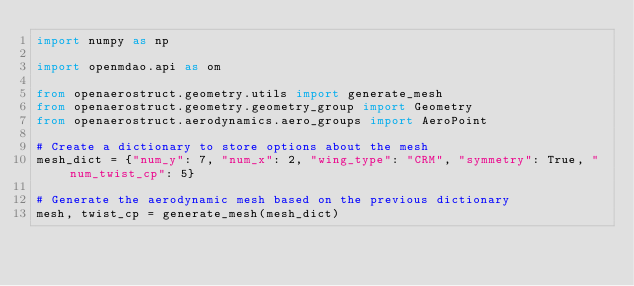Convert code to text. <code><loc_0><loc_0><loc_500><loc_500><_Python_>import numpy as np

import openmdao.api as om

from openaerostruct.geometry.utils import generate_mesh
from openaerostruct.geometry.geometry_group import Geometry
from openaerostruct.aerodynamics.aero_groups import AeroPoint

# Create a dictionary to store options about the mesh
mesh_dict = {"num_y": 7, "num_x": 2, "wing_type": "CRM", "symmetry": True, "num_twist_cp": 5}

# Generate the aerodynamic mesh based on the previous dictionary
mesh, twist_cp = generate_mesh(mesh_dict)
</code> 